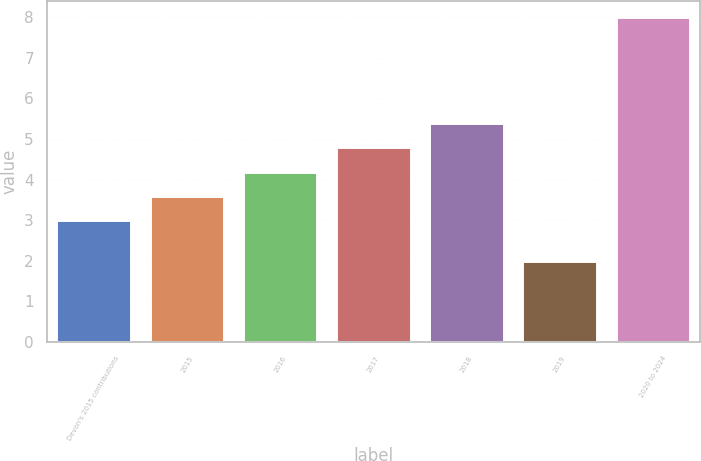Convert chart to OTSL. <chart><loc_0><loc_0><loc_500><loc_500><bar_chart><fcel>Devon's 2015 contributions<fcel>2015<fcel>2016<fcel>2017<fcel>2018<fcel>2019<fcel>2020 to 2024<nl><fcel>3<fcel>3.6<fcel>4.2<fcel>4.8<fcel>5.4<fcel>2<fcel>8<nl></chart> 